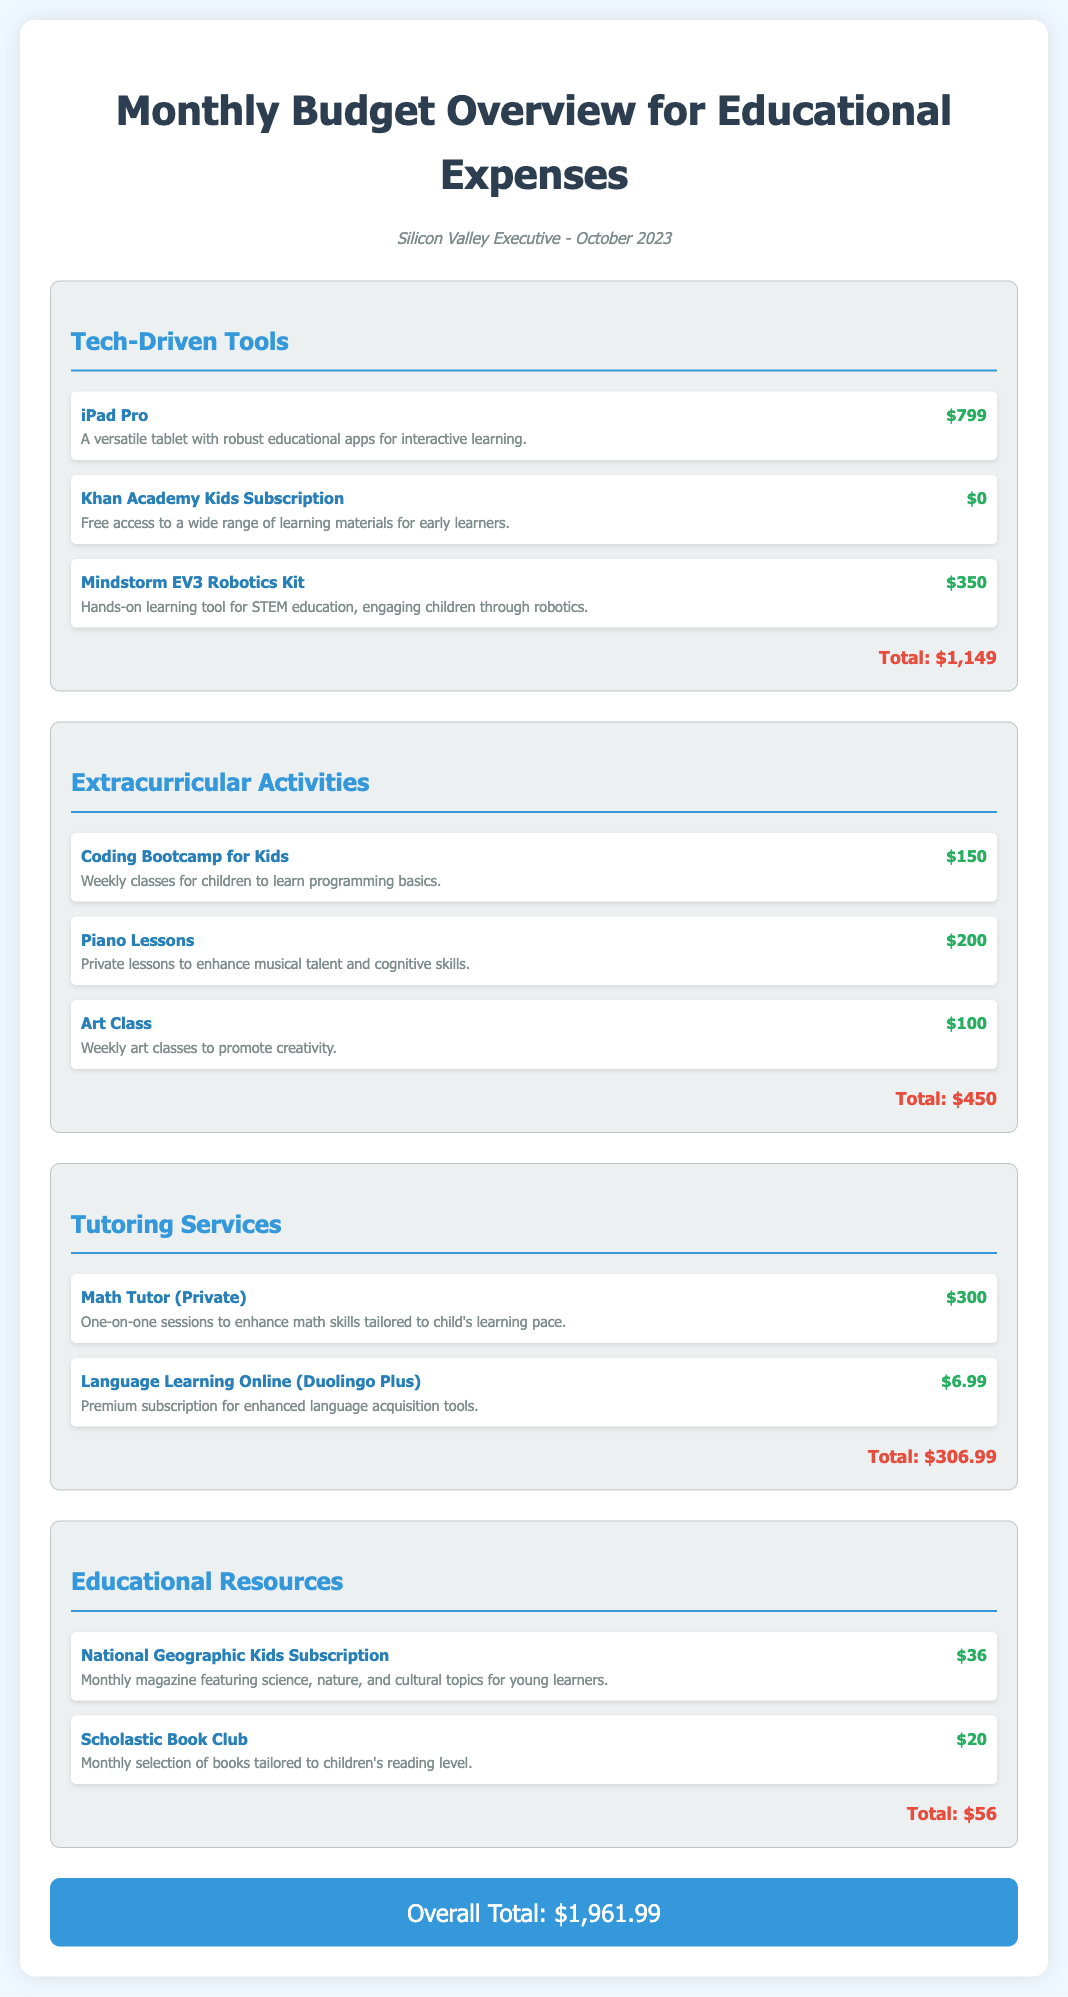what is the total cost for Tech-Driven Tools? The total cost for Tech-Driven Tools is listed at the bottom of the section, which sums the costs of all items in that category.
Answer: $1,149 how much does the Mindstorm EV3 Robotics Kit cost? The cost of the Mindstorm EV3 Robotics Kit is detailed in the Tech-Driven Tools section.
Answer: $350 what is included in the Extracurricular Activities category? The Extracurricular Activities category contains various items, specifically coding bootcamp, piano lessons, and art class.
Answer: Coding Bootcamp for Kids, Piano Lessons, Art Class what is the monthly cost for the National Geographic Kids Subscription? The document specifies the monthly cost of this subscription within the Educational Resources section.
Answer: $36 how much does the Language Learning Online (Duolingo Plus) service cost? The cost is provided as part of the Tutoring Services section information.
Answer: $6.99 what is the overall total for all educational expenses? The overall total combines the categories and is stated at the end of the document.
Answer: $1,961.99 how many items are listed under the Tutoring Services category? The Tutoring Services section contains a total of two items, as seen in the document.
Answer: 2 what kind of lessons does the Piano Lessons item offer? The description of the Piano Lessons item specifies what these lessons are meant for.
Answer: Private lessons to enhance musical talent and cognitive skills what is the cost of the coding bootcamp for kids? The price is stated alongside the coding bootcamp's description in the Extracurricular Activities section.
Answer: $150 